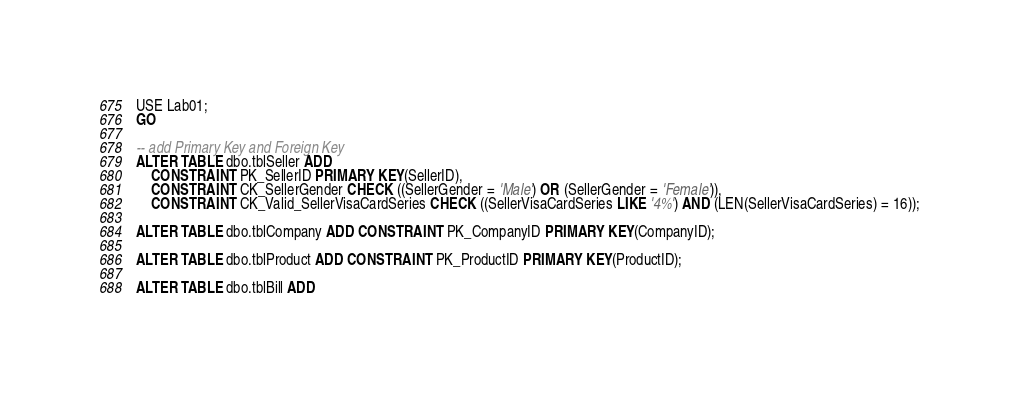Convert code to text. <code><loc_0><loc_0><loc_500><loc_500><_SQL_>USE Lab01;
GO

-- add Primary Key and Foreign Key
ALTER TABLE dbo.tblSeller ADD 
	CONSTRAINT PK_SellerID PRIMARY KEY(SellerID),
	CONSTRAINT CK_SellerGender CHECK ((SellerGender = 'Male') OR (SellerGender = 'Female')),
	CONSTRAINT CK_Valid_SellerVisaCardSeries CHECK ((SellerVisaCardSeries LIKE '4%') AND (LEN(SellerVisaCardSeries) = 16));

ALTER TABLE dbo.tblCompany ADD CONSTRAINT PK_CompanyID PRIMARY KEY(CompanyID);

ALTER TABLE dbo.tblProduct ADD CONSTRAINT PK_ProductID PRIMARY KEY(ProductID);

ALTER TABLE dbo.tblBill ADD</code> 